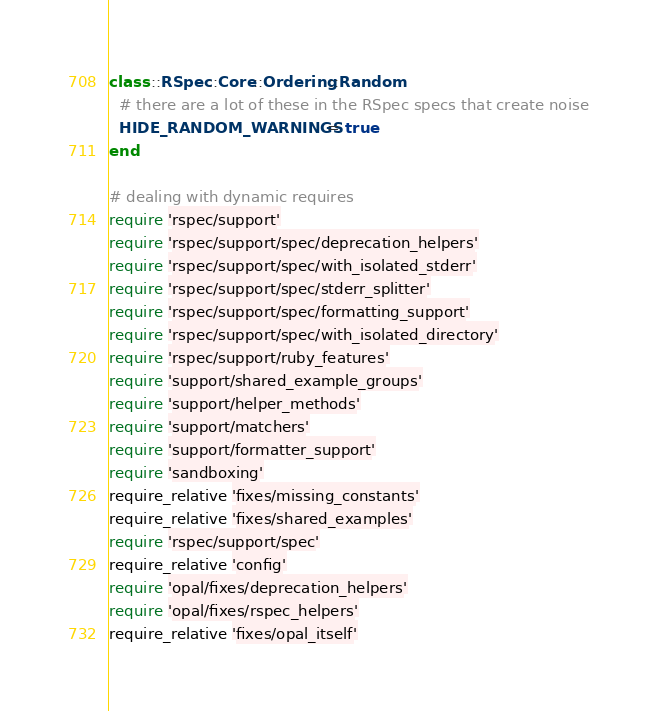<code> <loc_0><loc_0><loc_500><loc_500><_Ruby_>class ::RSpec::Core::Ordering::Random
  # there are a lot of these in the RSpec specs that create noise
  HIDE_RANDOM_WARNINGS = true
end

# dealing with dynamic requires
require 'rspec/support'
require 'rspec/support/spec/deprecation_helpers'
require 'rspec/support/spec/with_isolated_stderr'
require 'rspec/support/spec/stderr_splitter'
require 'rspec/support/spec/formatting_support'
require 'rspec/support/spec/with_isolated_directory'
require 'rspec/support/ruby_features'
require 'support/shared_example_groups'
require 'support/helper_methods'
require 'support/matchers'
require 'support/formatter_support'
require 'sandboxing'
require_relative 'fixes/missing_constants'
require_relative 'fixes/shared_examples'
require 'rspec/support/spec'
require_relative 'config'
require 'opal/fixes/deprecation_helpers'
require 'opal/fixes/rspec_helpers'
require_relative 'fixes/opal_itself'
</code> 